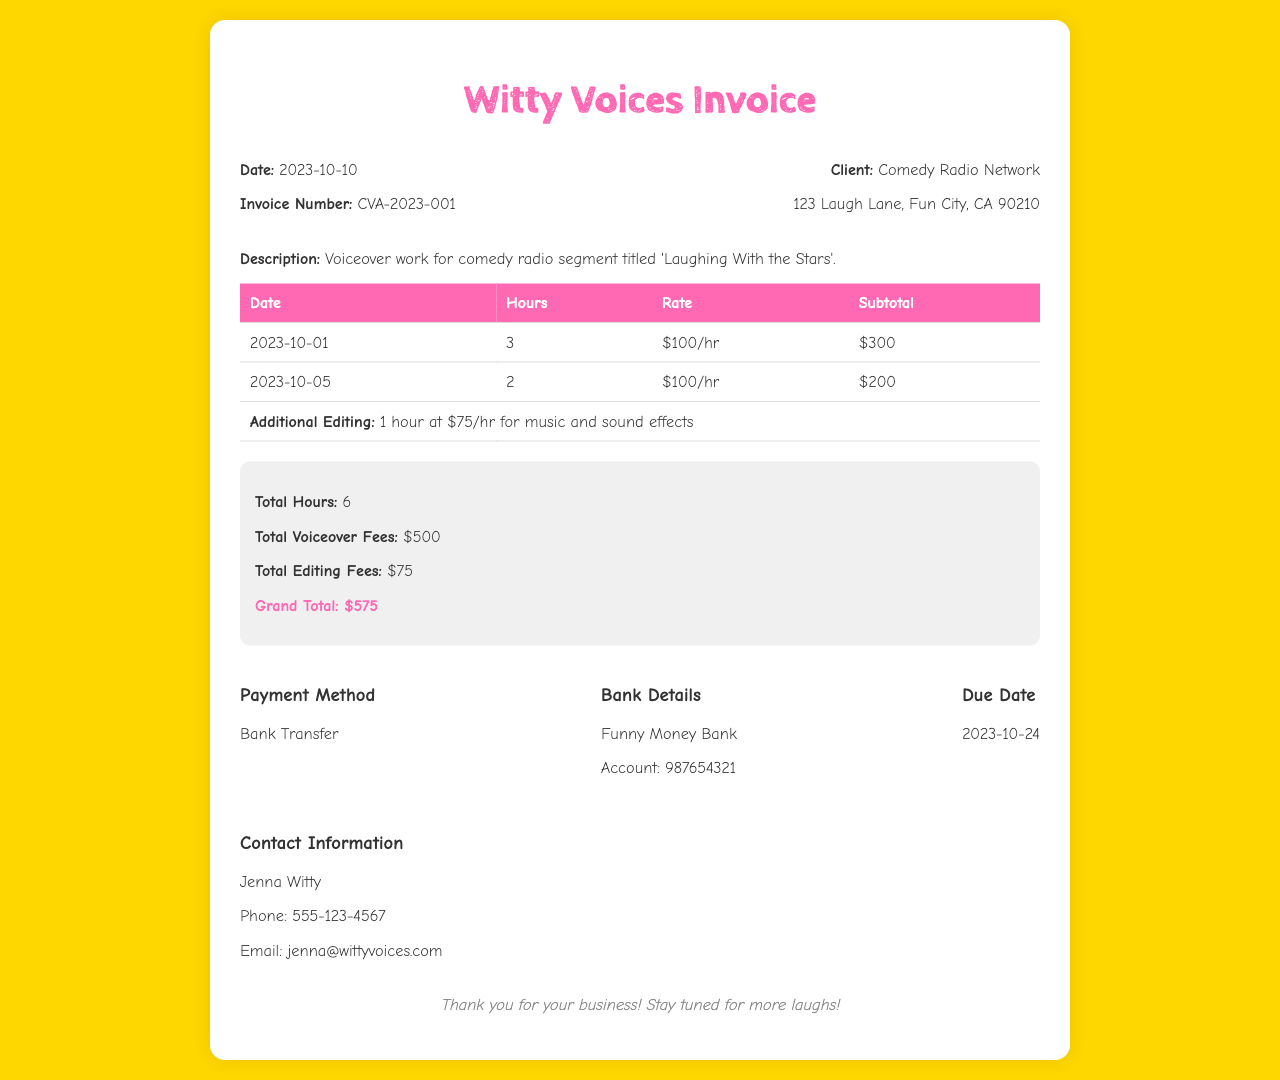What is the invoice number? The invoice number is listed in the document, which is CVA-2023-001.
Answer: CVA-2023-001 What is the date of the invoice? The date is provided in the header section of the document, noted as 2023-10-10.
Answer: 2023-10-10 What is the client's name? The client's name can be found under the client information, which is Comedy Radio Network.
Answer: Comedy Radio Network How many hours were billed for voiceover work? The total hours mentioned in the summary section of the invoice indicate there were 6 hours billed.
Answer: 6 What is the rate per hour for voiceover work? The rate is specified in the table for voiceover work as $100/hr.
Answer: $100/hr What is the total editing fee? The total editing fee is listed in the summary section, which is $75.
Answer: $75 What is the due date for payment? The due date is specified in the payment information section, which states it is on 2023-10-24.
Answer: 2023-10-24 What is the grand total amount due? The grand total is the final sum in the summary section, indicated as $575.
Answer: $575 What payment method is accepted? The document mentions the payment method in the payment information section, which is Bank Transfer.
Answer: Bank Transfer 